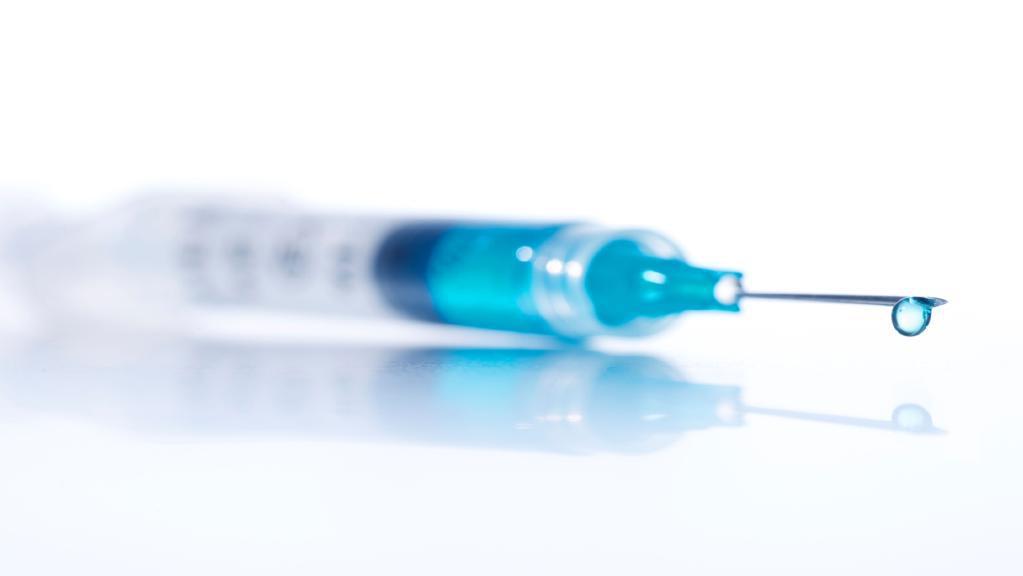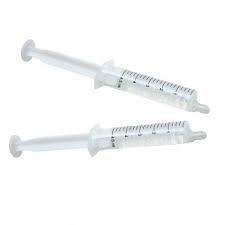The first image is the image on the left, the second image is the image on the right. Considering the images on both sides, is "An image features exactly one syringe with an exposed needle tip." valid? Answer yes or no. Yes. The first image is the image on the left, the second image is the image on the right. Examine the images to the left and right. Is the description "There are four or more syringes in total." accurate? Answer yes or no. No. 